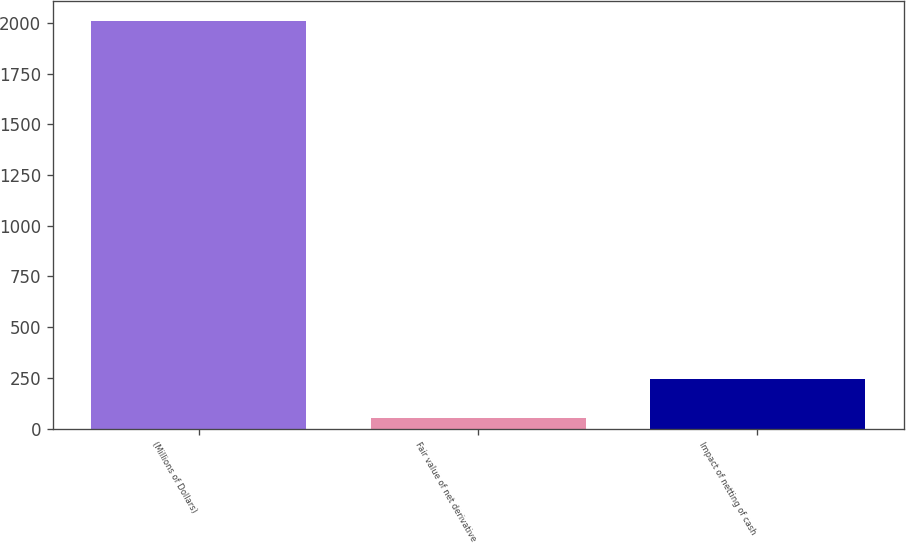<chart> <loc_0><loc_0><loc_500><loc_500><bar_chart><fcel>(Millions of Dollars)<fcel>Fair value of net derivative<fcel>Impact of netting of cash<nl><fcel>2009<fcel>50<fcel>245.9<nl></chart> 